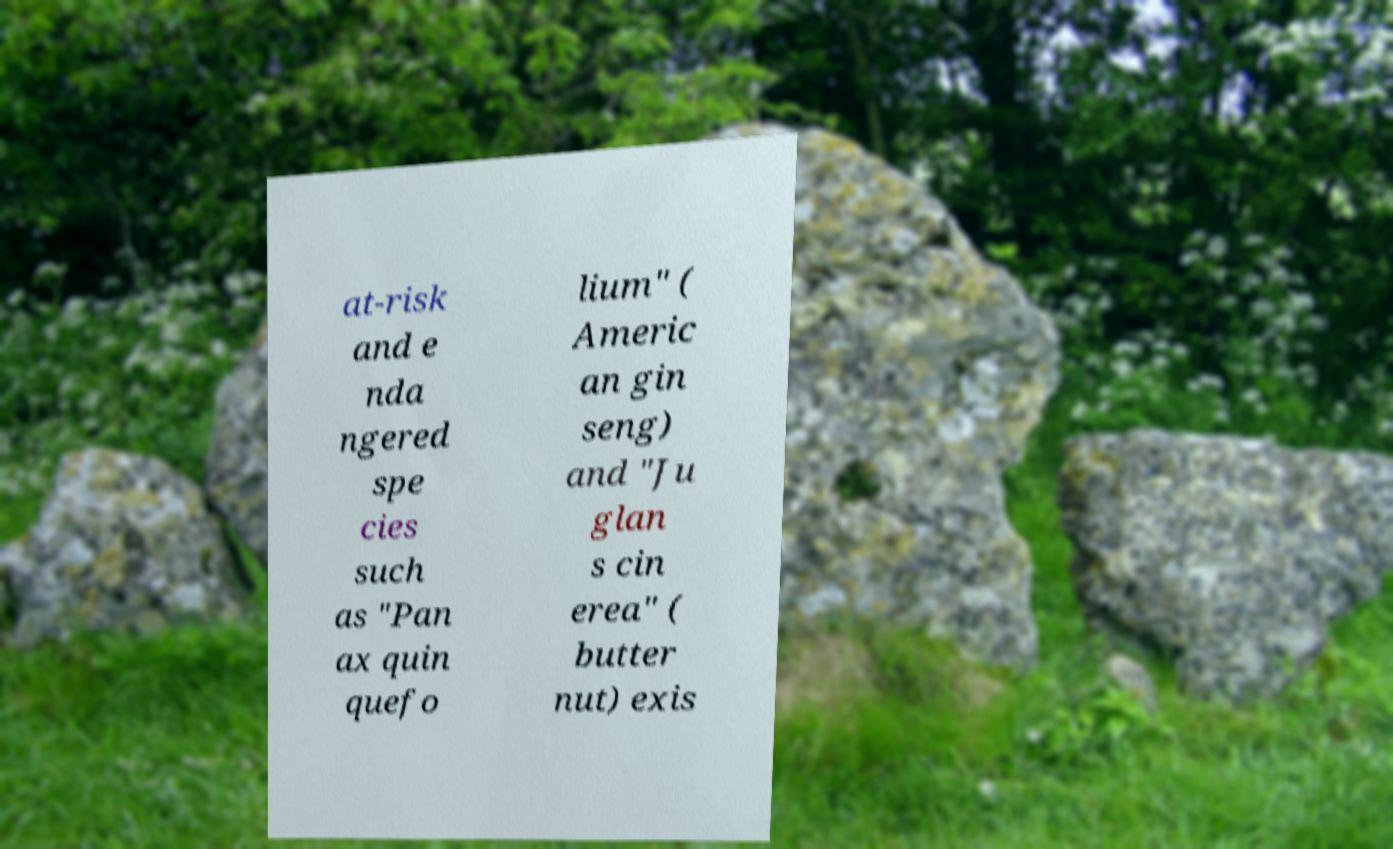Could you extract and type out the text from this image? at-risk and e nda ngered spe cies such as "Pan ax quin quefo lium" ( Americ an gin seng) and "Ju glan s cin erea" ( butter nut) exis 